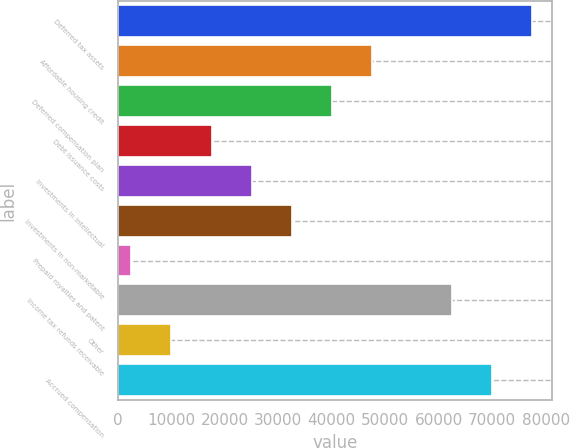Convert chart. <chart><loc_0><loc_0><loc_500><loc_500><bar_chart><fcel>Deferred tax assets<fcel>Affordable housing credit<fcel>Deferred compensation plan<fcel>Debt issuance costs<fcel>Investments in intellectual<fcel>Investments in non-marketable<fcel>Prepaid royalties and patent<fcel>Income tax refunds receivable<fcel>Other<fcel>Accrued compensation<nl><fcel>77387<fcel>47454.6<fcel>39971.5<fcel>17522.2<fcel>25005.3<fcel>32488.4<fcel>2556<fcel>62420.8<fcel>10039.1<fcel>69903.9<nl></chart> 